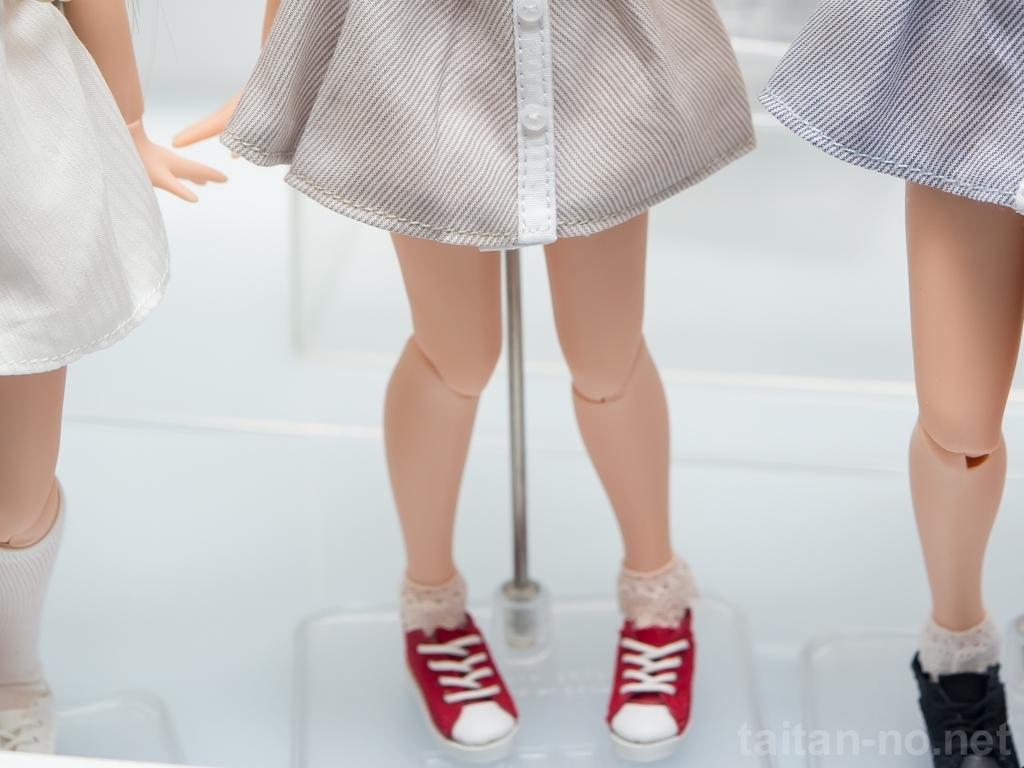How is the composition of the image?
A. Incomplete
B. Balanced
C. Perfectly framed
D. Well-composed While the image appears to be 'Well-composed' with symmetrical placement of the two figures, it is essential to consider that the composition might feel incomplete (A) to some viewers, as it only includes the lower half of the subjects, cutting off at the waist and not showing the full bodies or faces. This choice can be seen as intentional to focus on the outfits and footwear, evoking curiosity about the unseen parts of the figures. 